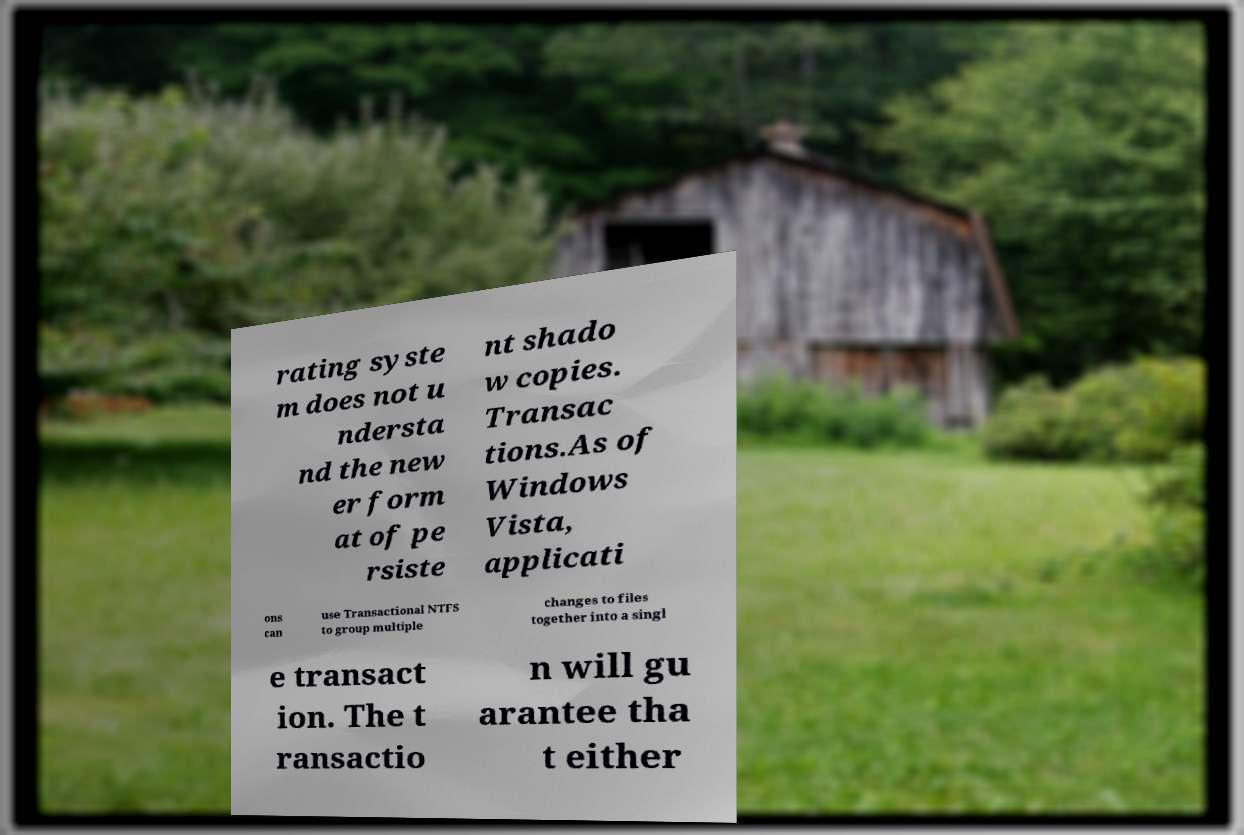Could you extract and type out the text from this image? rating syste m does not u ndersta nd the new er form at of pe rsiste nt shado w copies. Transac tions.As of Windows Vista, applicati ons can use Transactional NTFS to group multiple changes to files together into a singl e transact ion. The t ransactio n will gu arantee tha t either 